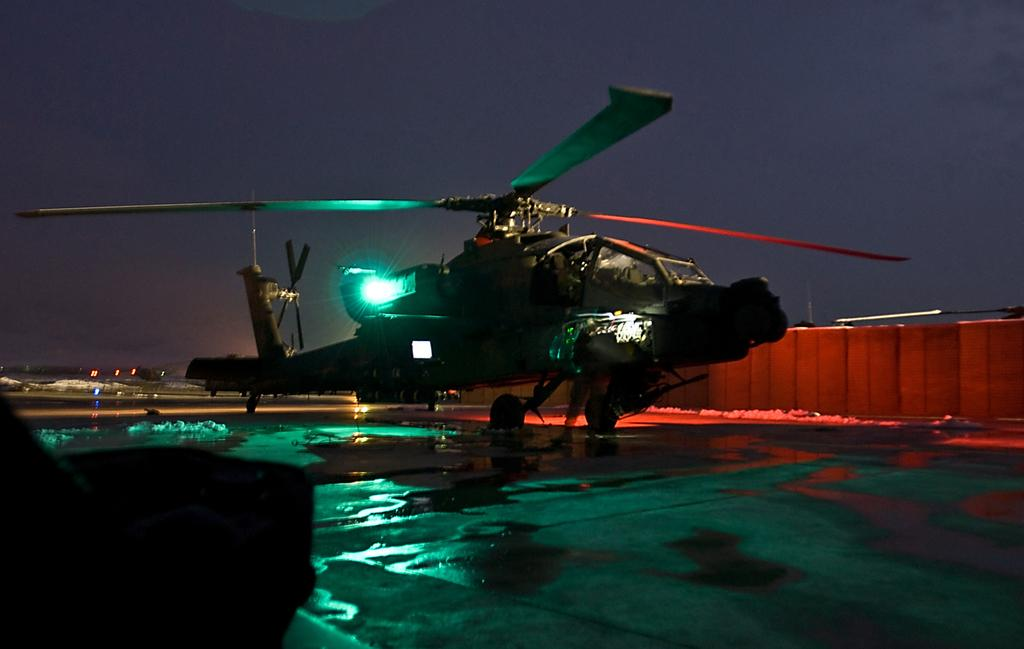What is the main subject of the image? The main subject of the image is a helicopter. What is the helicopter's current position in the image? The helicopter is on the ground in the image. Are there any specific features of the helicopter that can be seen? Yes, the helicopter has lights. What can be seen in the background of the image? The sky is visible in the background of the image. What is the reaction of the helicopter to the step in the image? There is no step present in the image, and therefore no reaction can be observed from the helicopter. What type of love is depicted between the helicopter and the wall in the image? There is no depiction of love between the helicopter and the wall in the image; they are separate objects. 